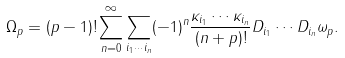Convert formula to latex. <formula><loc_0><loc_0><loc_500><loc_500>\Omega _ { p } = ( p - 1 ) ! \sum _ { n = 0 } ^ { \infty } \sum _ { i _ { 1 } \cdots i _ { n } } ( - 1 ) ^ { n } \frac { \kappa _ { i _ { 1 } } \cdots \kappa _ { i _ { n } } } { ( n + p ) ! } D _ { i _ { 1 } } \cdots D _ { i _ { n } } \omega _ { p } .</formula> 